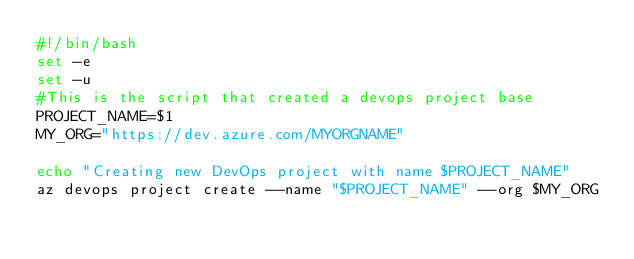<code> <loc_0><loc_0><loc_500><loc_500><_Bash_>#!/bin/bash
set -e
set -u
#This is the script that created a devops project base
PROJECT_NAME=$1
MY_ORG="https://dev.azure.com/MYORGNAME"

echo "Creating new DevOps project with name $PROJECT_NAME"
az devops project create --name "$PROJECT_NAME" --org $MY_ORG
</code> 